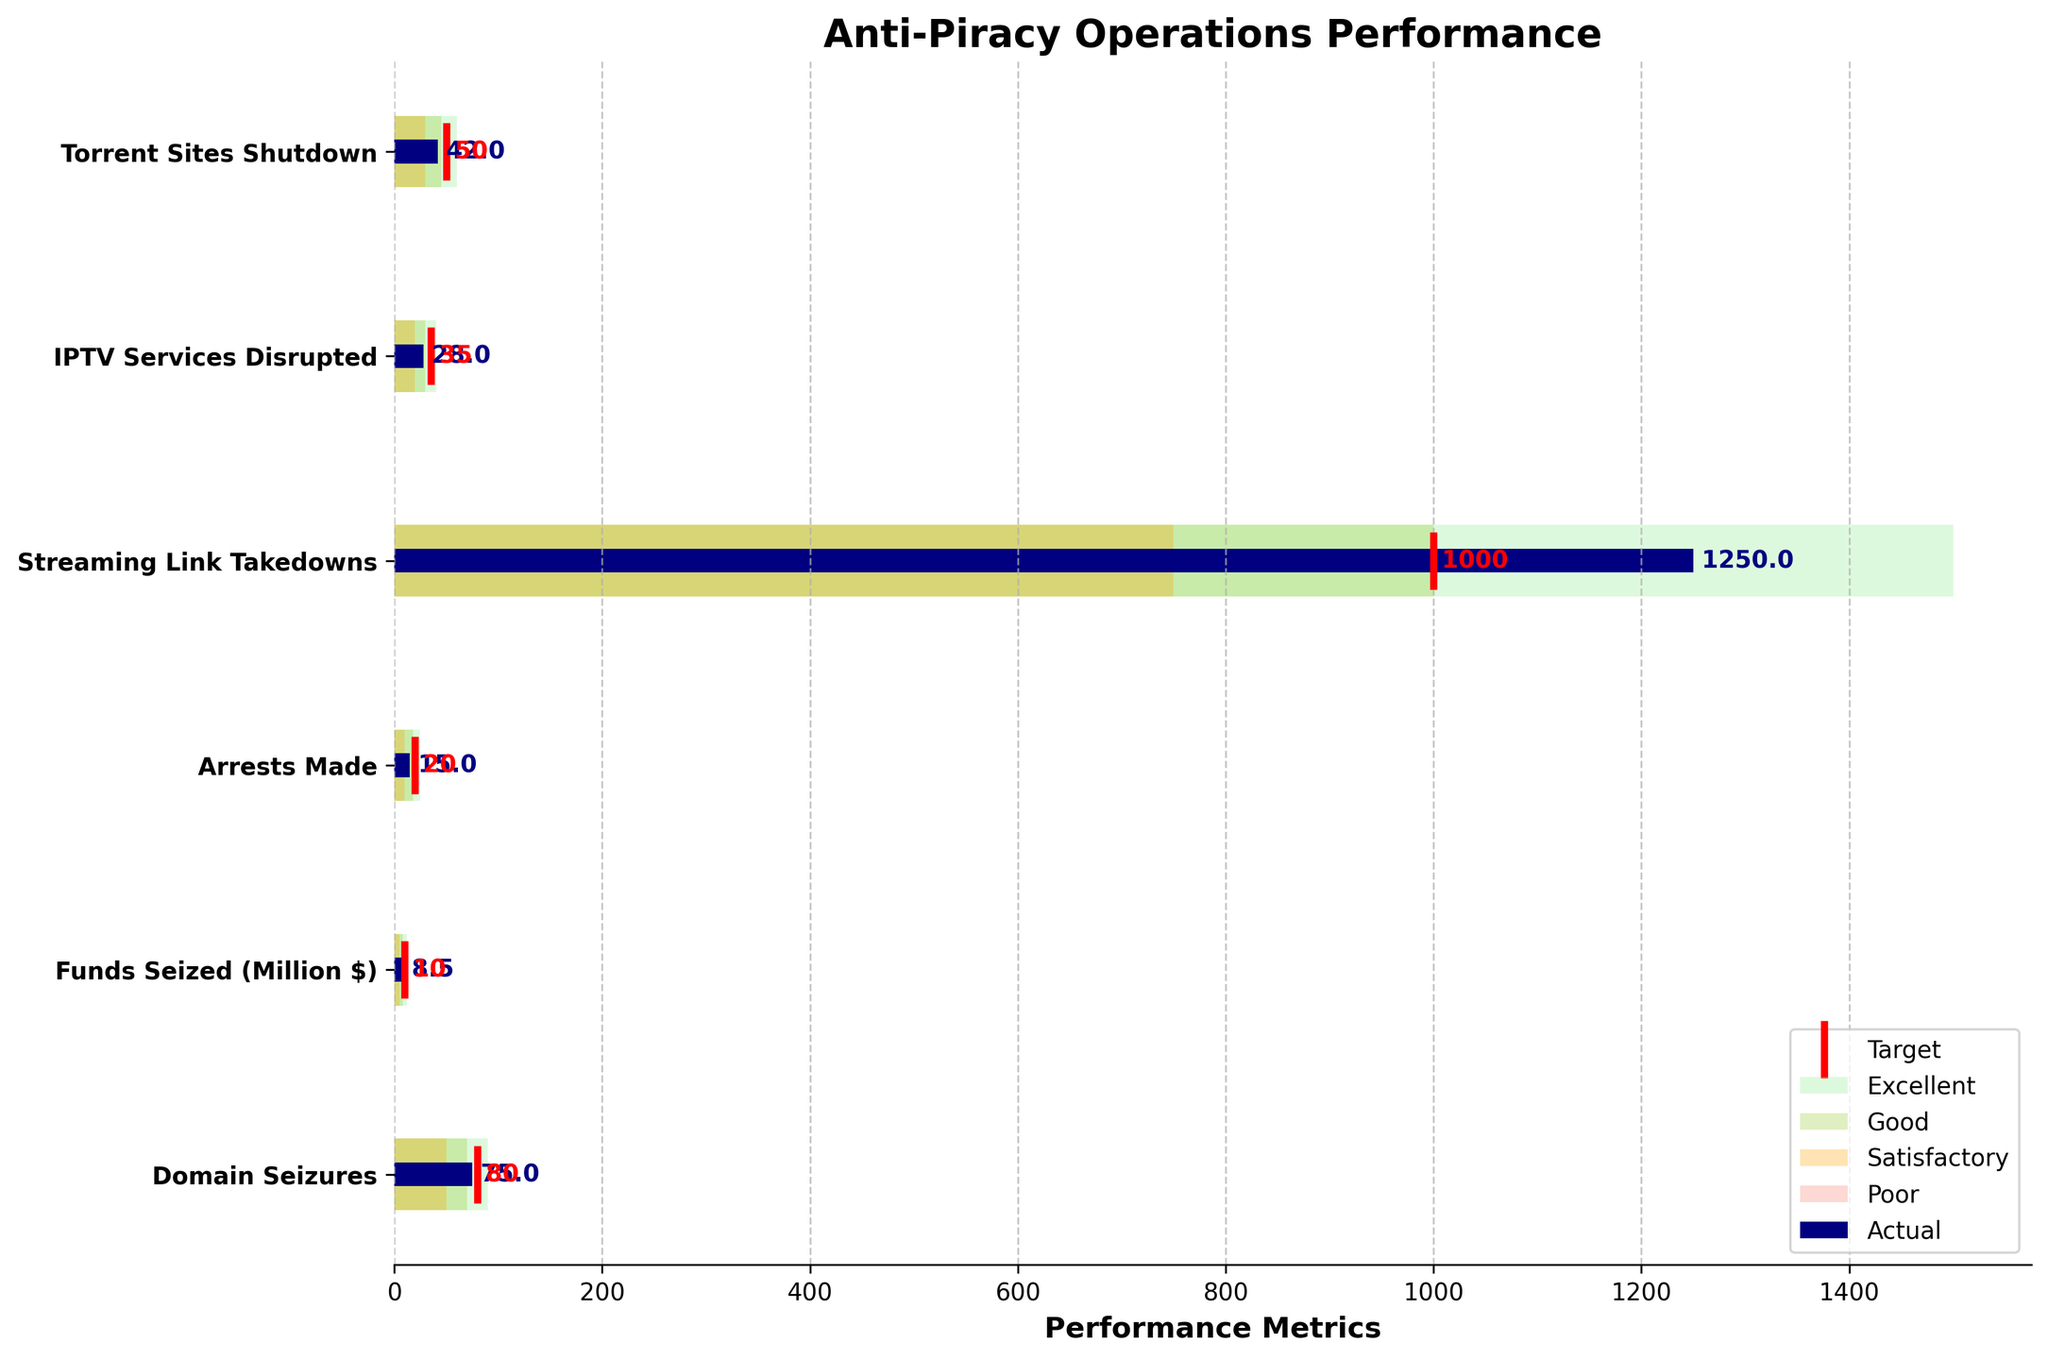What category achieved the highest actual value? By inspecting the horizontal bars, the "Streaming Link Takedowns" has the longest bar representing an actual value of 1250.
Answer: Streaming Link Takedowns What is the title of the chart? The title is prominently displayed at the top of the chart. It reads "Anti-Piracy Operations Performance."
Answer: Anti-Piracy Operations Performance Which category is closest to its target value? Compare the difference between the actual and target values for all categories. "Streaming Link Takedowns" has an actual value of 1250 compared to a target of 1000, which is the closest accomplishment.
Answer: Streaming Link Takedowns How many categories fall into the "Excellent" range? The "Excellent" range is indicated by light green segments. We count the segments for categories within this range: "Streaming Link Takedowns" and "Domain Seizures" are the two categories within this range.
Answer: 2 Which category shows the largest gap below its target? By looking at the horizontal lines marking the targets, "Torrent Sites Shutdown" has an actual value of 42 and a target of 50, showing a gap of 8.
Answer: Torrent Sites Shutdown What is the actual value for "IPTV Services Disrupted"? The actual value is directly labeled on the horizontal bar for "IPTV Services Disrupted" and it reads 28.
Answer: 28 Among all categories, which one performed below the "Poor" range? Verify the bars that do not even reach the first segment marking "Poor". All categories at least reach the "Poor" benchmark, so none fall below it.
Answer: None What is the average target value across all categories? Sum up all the target values (50 + 35 + 1000 + 20 + 10 + 80 = 1195), and divide by the number of categories (6). The average is 199.17.
Answer: 199.17 Which two categories lie within the "Satisfactory" and "Good" ranges but did not fall into "Excellent"? By observing the orange and yellowgreen ranges and checking categories whose bars fall within them but not into "Excellent"; "Torrent Sites Shutdown" and "IPTV Services Disrupted" fit this description.
Answer: Torrent Sites Shutdown, IPTV Services Disrupted What category has an actual value closest to its satisfactory range? The "Satisfactory" range is represented by the orange segments. "Funds Seized (Million $)" has an actual value of 8.5, which is closest to its satisfactory range of 8.
Answer: Funds Seized (Million $) 